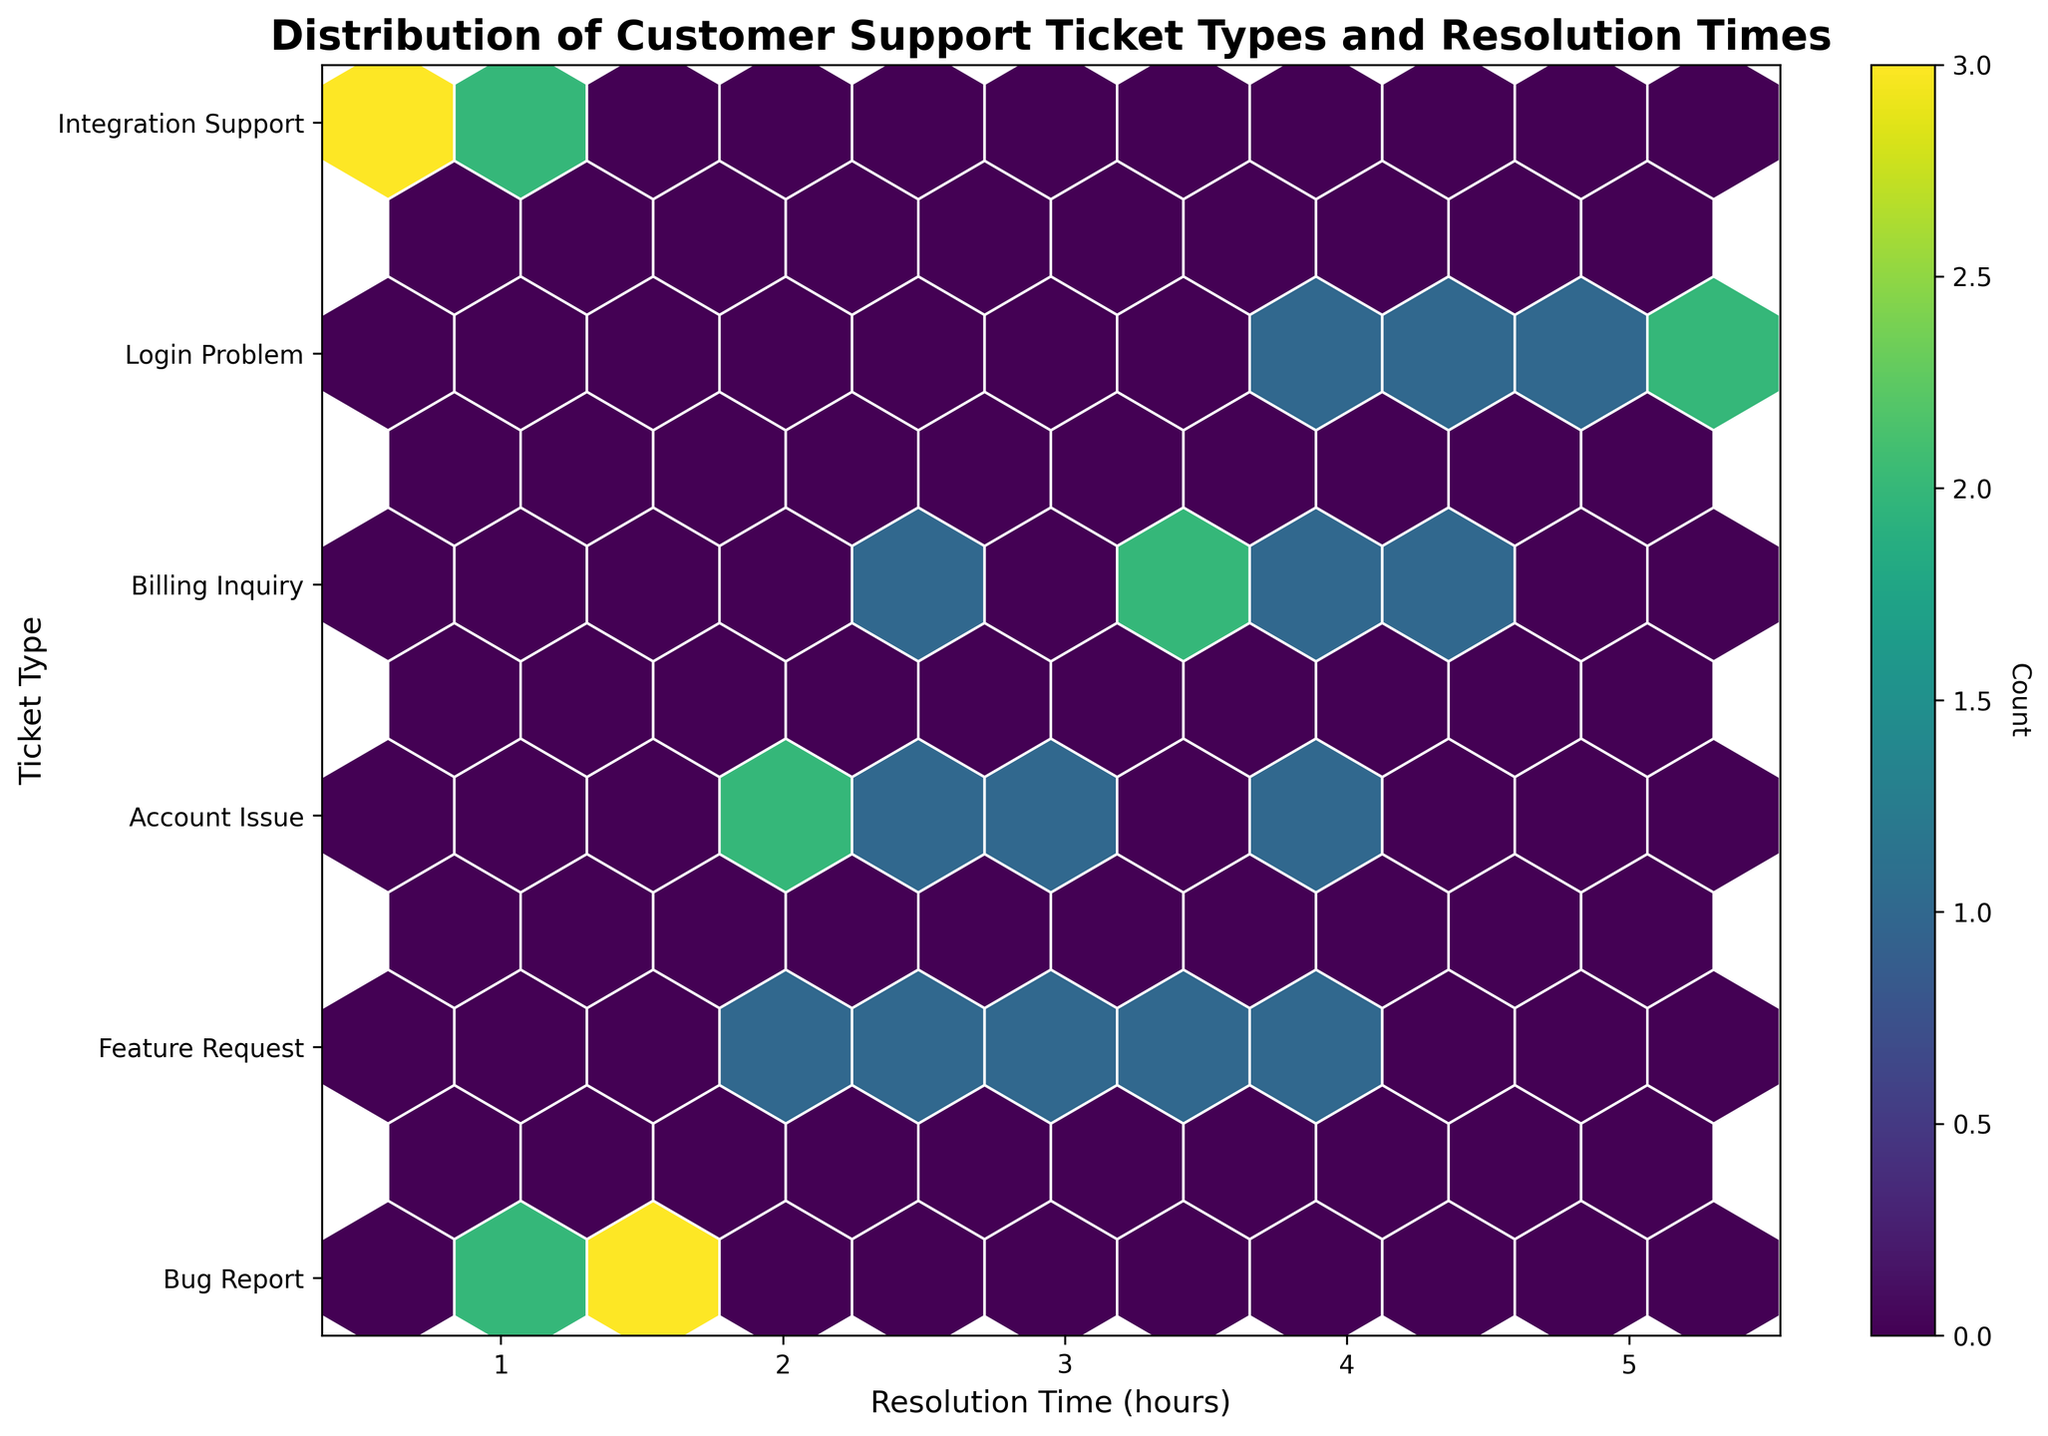How many ticket types are displayed on the y-axis? The y-axis ticks correspond to the unique ticket types shown in the plot. By counting the distinct labels, we can find the number of ticket types.
Answer: 6 What is the range of resolution times on the x-axis? The x-axis represents "Resolution Time (hours)." Observing the plot, we can see the minimum and maximum values marked on the axis.
Answer: 0 - 6 hours Which ticket type has the highest concentration of data points? By looking at the density of the hexagons for each ticket type on the y-axis, we can identify which one has the most filled hexagons.
Answer: Bug Report Are there more "Feature Request" or "Billing Inquiry" tickets with resolution times below 3 hours? To answer this, count the hexagons below 3 hours on the x-axis for both "Feature Request" and "Billing Inquiry" and compare.
Answer: Feature Request What is the most common resolution time range for "Integration Support" tickets? Observe the areas where hexagons are densest along the x-axis for "Integration Support." This will indicate the most common resolution time range.
Answer: 4-5 hours Does any ticket type have a resolution time exceeding 5 hours? Look at the x-axis for values above 5 hours and check if any hexagons lie in this region for any ticket types.
Answer: Yes What is the color of the hexagons with the highest count in the plot? Examine the colorbar provided with the plot to identify the color that corresponds to the highest count.
Answer: Dark purple Which ticket type has more varied resolution times? Determine this by looking at the spread of hexagons along the x-axis for each ticket type. A wider spread indicates more varied resolution times.
Answer: Integration Support Are there any ticket types that resolve quicker than 1 hour? Look at the leftmost part of the x-axis (below 1 hour) and check if any hexagons correspond to any of the ticket types.
Answer: Yes, Login Problem Comparing "Account Issue" and "Login Problem," which has a higher count of points with a resolution time between 0.5 to 1 hour? Check the number of hexagons in the range of 0.5 to 1 hour for both "Account Issue" and "Login Problem," and see which has more.
Answer: Login Problem 